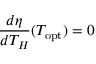Convert formula to latex. <formula><loc_0><loc_0><loc_500><loc_500>{ \frac { d \eta } { d T _ { H } } } ( T _ { o p t } ) = 0</formula> 